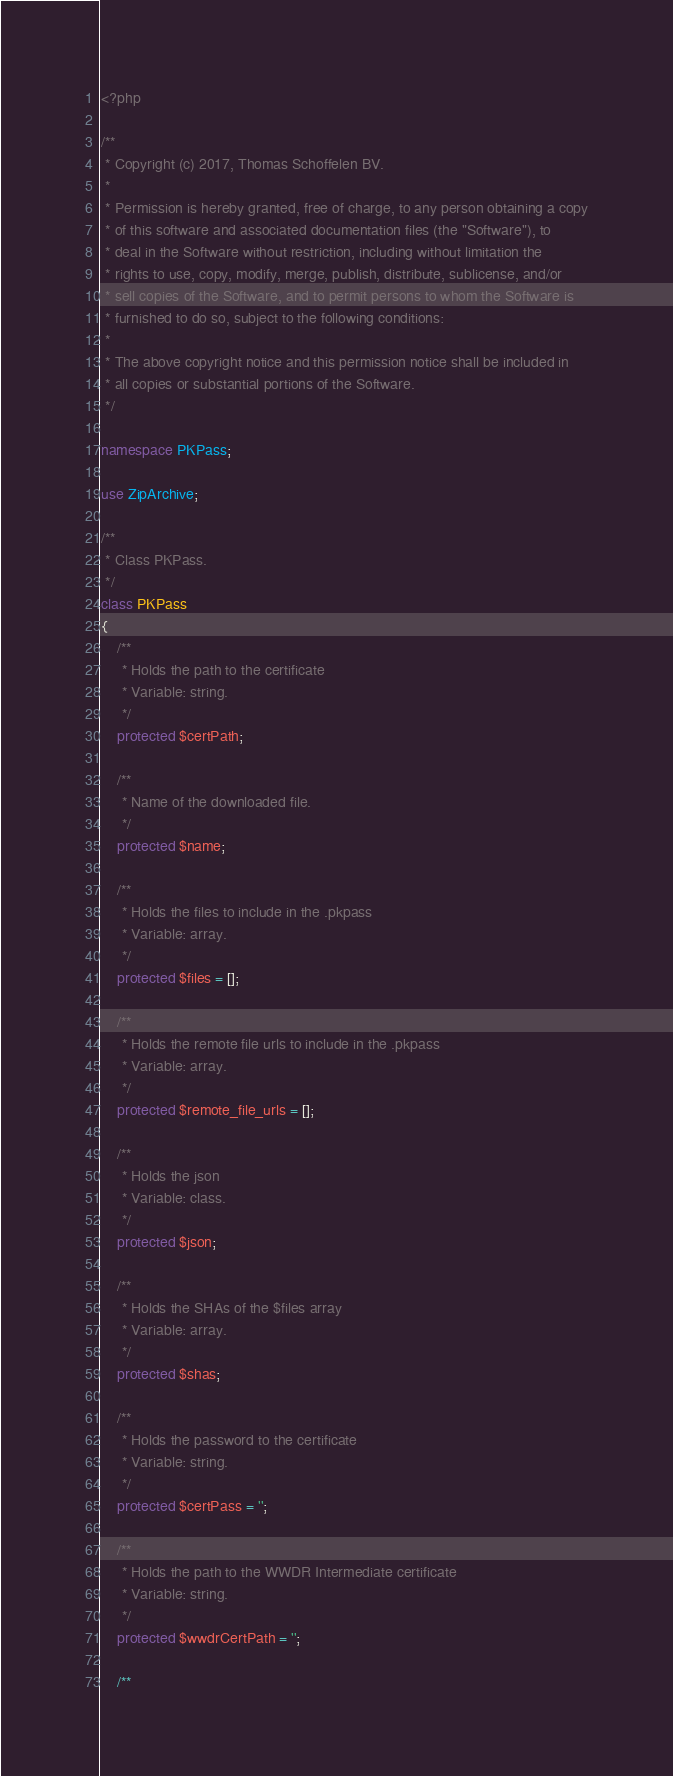<code> <loc_0><loc_0><loc_500><loc_500><_PHP_><?php

/**
 * Copyright (c) 2017, Thomas Schoffelen BV.
 *
 * Permission is hereby granted, free of charge, to any person obtaining a copy
 * of this software and associated documentation files (the "Software"), to
 * deal in the Software without restriction, including without limitation the
 * rights to use, copy, modify, merge, publish, distribute, sublicense, and/or
 * sell copies of the Software, and to permit persons to whom the Software is
 * furnished to do so, subject to the following conditions:
 *
 * The above copyright notice and this permission notice shall be included in
 * all copies or substantial portions of the Software.
 */

namespace PKPass;

use ZipArchive;

/**
 * Class PKPass.
 */
class PKPass
{
    /**
     * Holds the path to the certificate
     * Variable: string.
     */
    protected $certPath;

    /**
     * Name of the downloaded file.
     */
    protected $name;

    /**
     * Holds the files to include in the .pkpass
     * Variable: array.
     */
    protected $files = [];

    /**
     * Holds the remote file urls to include in the .pkpass
     * Variable: array.
     */
    protected $remote_file_urls = [];

    /**
     * Holds the json
     * Variable: class.
     */
    protected $json;

    /**
     * Holds the SHAs of the $files array
     * Variable: array.
     */
    protected $shas;

    /**
     * Holds the password to the certificate
     * Variable: string.
     */
    protected $certPass = '';

    /**
     * Holds the path to the WWDR Intermediate certificate
     * Variable: string.
     */
    protected $wwdrCertPath = '';

    /**</code> 